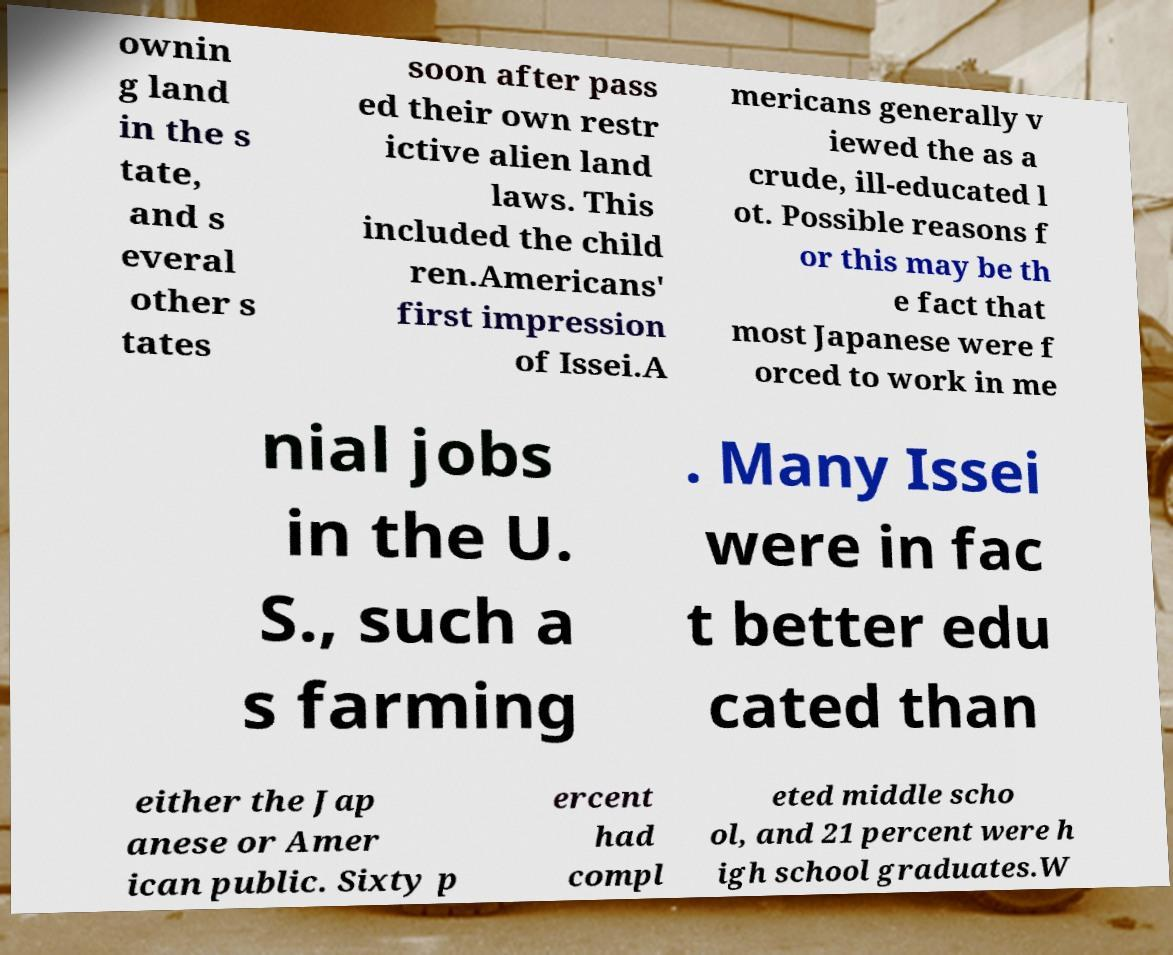What messages or text are displayed in this image? I need them in a readable, typed format. ownin g land in the s tate, and s everal other s tates soon after pass ed their own restr ictive alien land laws. This included the child ren.Americans' first impression of Issei.A mericans generally v iewed the as a crude, ill-educated l ot. Possible reasons f or this may be th e fact that most Japanese were f orced to work in me nial jobs in the U. S., such a s farming . Many Issei were in fac t better edu cated than either the Jap anese or Amer ican public. Sixty p ercent had compl eted middle scho ol, and 21 percent were h igh school graduates.W 